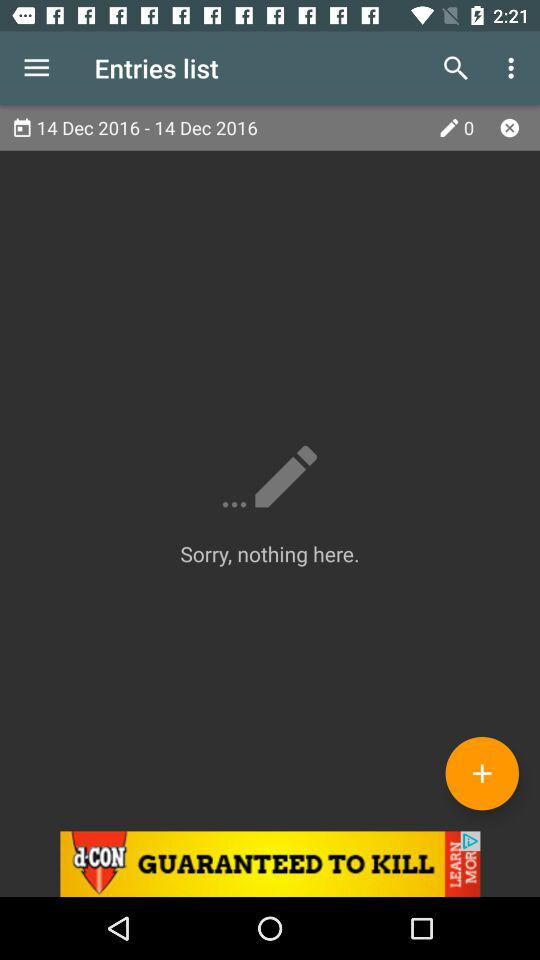How many days does the date range cover?
Answer the question using a single word or phrase. 1 